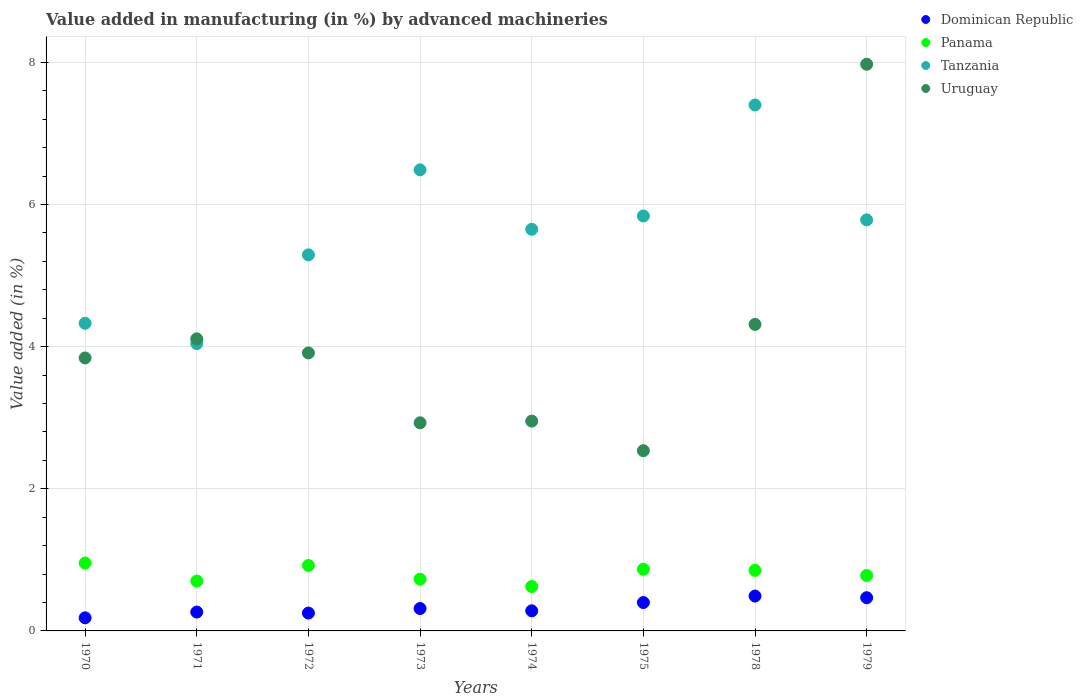What is the percentage of value added in manufacturing by advanced machineries in Dominican Republic in 1979?
Your response must be concise. 0.47. Across all years, what is the maximum percentage of value added in manufacturing by advanced machineries in Panama?
Make the answer very short. 0.95. Across all years, what is the minimum percentage of value added in manufacturing by advanced machineries in Panama?
Provide a succinct answer. 0.62. In which year was the percentage of value added in manufacturing by advanced machineries in Dominican Republic maximum?
Your answer should be compact. 1978. In which year was the percentage of value added in manufacturing by advanced machineries in Tanzania minimum?
Ensure brevity in your answer.  1971. What is the total percentage of value added in manufacturing by advanced machineries in Panama in the graph?
Keep it short and to the point. 6.43. What is the difference between the percentage of value added in manufacturing by advanced machineries in Uruguay in 1972 and that in 1975?
Give a very brief answer. 1.38. What is the difference between the percentage of value added in manufacturing by advanced machineries in Dominican Republic in 1972 and the percentage of value added in manufacturing by advanced machineries in Tanzania in 1970?
Your response must be concise. -4.08. What is the average percentage of value added in manufacturing by advanced machineries in Panama per year?
Your answer should be compact. 0.8. In the year 1978, what is the difference between the percentage of value added in manufacturing by advanced machineries in Panama and percentage of value added in manufacturing by advanced machineries in Tanzania?
Offer a very short reply. -6.55. In how many years, is the percentage of value added in manufacturing by advanced machineries in Panama greater than 0.4 %?
Ensure brevity in your answer.  8. What is the ratio of the percentage of value added in manufacturing by advanced machineries in Tanzania in 1974 to that in 1979?
Your answer should be very brief. 0.98. Is the difference between the percentage of value added in manufacturing by advanced machineries in Panama in 1970 and 1975 greater than the difference between the percentage of value added in manufacturing by advanced machineries in Tanzania in 1970 and 1975?
Your answer should be compact. Yes. What is the difference between the highest and the second highest percentage of value added in manufacturing by advanced machineries in Dominican Republic?
Keep it short and to the point. 0.02. What is the difference between the highest and the lowest percentage of value added in manufacturing by advanced machineries in Panama?
Give a very brief answer. 0.33. In how many years, is the percentage of value added in manufacturing by advanced machineries in Dominican Republic greater than the average percentage of value added in manufacturing by advanced machineries in Dominican Republic taken over all years?
Ensure brevity in your answer.  3. Is the sum of the percentage of value added in manufacturing by advanced machineries in Uruguay in 1970 and 1979 greater than the maximum percentage of value added in manufacturing by advanced machineries in Panama across all years?
Your answer should be compact. Yes. Does the percentage of value added in manufacturing by advanced machineries in Panama monotonically increase over the years?
Offer a terse response. No. Is the percentage of value added in manufacturing by advanced machineries in Uruguay strictly greater than the percentage of value added in manufacturing by advanced machineries in Tanzania over the years?
Ensure brevity in your answer.  No. Is the percentage of value added in manufacturing by advanced machineries in Dominican Republic strictly less than the percentage of value added in manufacturing by advanced machineries in Uruguay over the years?
Your answer should be very brief. Yes. How many dotlines are there?
Your response must be concise. 4. What is the difference between two consecutive major ticks on the Y-axis?
Provide a short and direct response. 2. Does the graph contain grids?
Give a very brief answer. Yes. How are the legend labels stacked?
Make the answer very short. Vertical. What is the title of the graph?
Keep it short and to the point. Value added in manufacturing (in %) by advanced machineries. What is the label or title of the Y-axis?
Your answer should be very brief. Value added (in %). What is the Value added (in %) of Dominican Republic in 1970?
Your answer should be very brief. 0.18. What is the Value added (in %) in Panama in 1970?
Your response must be concise. 0.95. What is the Value added (in %) in Tanzania in 1970?
Your answer should be very brief. 4.33. What is the Value added (in %) of Uruguay in 1970?
Offer a terse response. 3.84. What is the Value added (in %) in Dominican Republic in 1971?
Give a very brief answer. 0.27. What is the Value added (in %) of Panama in 1971?
Your response must be concise. 0.7. What is the Value added (in %) in Tanzania in 1971?
Ensure brevity in your answer.  4.04. What is the Value added (in %) of Uruguay in 1971?
Your answer should be very brief. 4.11. What is the Value added (in %) of Dominican Republic in 1972?
Give a very brief answer. 0.25. What is the Value added (in %) of Panama in 1972?
Your answer should be compact. 0.92. What is the Value added (in %) of Tanzania in 1972?
Make the answer very short. 5.29. What is the Value added (in %) in Uruguay in 1972?
Offer a terse response. 3.91. What is the Value added (in %) of Dominican Republic in 1973?
Your answer should be compact. 0.32. What is the Value added (in %) in Panama in 1973?
Your response must be concise. 0.73. What is the Value added (in %) of Tanzania in 1973?
Make the answer very short. 6.49. What is the Value added (in %) in Uruguay in 1973?
Provide a succinct answer. 2.93. What is the Value added (in %) of Dominican Republic in 1974?
Keep it short and to the point. 0.28. What is the Value added (in %) of Panama in 1974?
Offer a very short reply. 0.62. What is the Value added (in %) in Tanzania in 1974?
Your response must be concise. 5.65. What is the Value added (in %) in Uruguay in 1974?
Ensure brevity in your answer.  2.95. What is the Value added (in %) of Dominican Republic in 1975?
Your answer should be very brief. 0.4. What is the Value added (in %) of Panama in 1975?
Ensure brevity in your answer.  0.87. What is the Value added (in %) in Tanzania in 1975?
Make the answer very short. 5.84. What is the Value added (in %) of Uruguay in 1975?
Provide a succinct answer. 2.54. What is the Value added (in %) of Dominican Republic in 1978?
Ensure brevity in your answer.  0.49. What is the Value added (in %) in Panama in 1978?
Offer a very short reply. 0.85. What is the Value added (in %) of Tanzania in 1978?
Make the answer very short. 7.4. What is the Value added (in %) of Uruguay in 1978?
Provide a succinct answer. 4.31. What is the Value added (in %) of Dominican Republic in 1979?
Provide a short and direct response. 0.47. What is the Value added (in %) in Panama in 1979?
Your answer should be very brief. 0.78. What is the Value added (in %) of Tanzania in 1979?
Offer a terse response. 5.78. What is the Value added (in %) of Uruguay in 1979?
Provide a short and direct response. 7.97. Across all years, what is the maximum Value added (in %) of Dominican Republic?
Your response must be concise. 0.49. Across all years, what is the maximum Value added (in %) of Panama?
Provide a short and direct response. 0.95. Across all years, what is the maximum Value added (in %) in Tanzania?
Make the answer very short. 7.4. Across all years, what is the maximum Value added (in %) in Uruguay?
Your answer should be compact. 7.97. Across all years, what is the minimum Value added (in %) in Dominican Republic?
Your response must be concise. 0.18. Across all years, what is the minimum Value added (in %) of Panama?
Your answer should be compact. 0.62. Across all years, what is the minimum Value added (in %) of Tanzania?
Offer a terse response. 4.04. Across all years, what is the minimum Value added (in %) of Uruguay?
Ensure brevity in your answer.  2.54. What is the total Value added (in %) of Dominican Republic in the graph?
Make the answer very short. 2.66. What is the total Value added (in %) of Panama in the graph?
Your response must be concise. 6.43. What is the total Value added (in %) in Tanzania in the graph?
Provide a short and direct response. 44.82. What is the total Value added (in %) of Uruguay in the graph?
Offer a terse response. 32.56. What is the difference between the Value added (in %) of Dominican Republic in 1970 and that in 1971?
Offer a terse response. -0.08. What is the difference between the Value added (in %) of Panama in 1970 and that in 1971?
Make the answer very short. 0.25. What is the difference between the Value added (in %) of Tanzania in 1970 and that in 1971?
Provide a succinct answer. 0.29. What is the difference between the Value added (in %) in Uruguay in 1970 and that in 1971?
Give a very brief answer. -0.27. What is the difference between the Value added (in %) of Dominican Republic in 1970 and that in 1972?
Give a very brief answer. -0.07. What is the difference between the Value added (in %) in Panama in 1970 and that in 1972?
Make the answer very short. 0.03. What is the difference between the Value added (in %) of Tanzania in 1970 and that in 1972?
Offer a terse response. -0.96. What is the difference between the Value added (in %) of Uruguay in 1970 and that in 1972?
Provide a succinct answer. -0.07. What is the difference between the Value added (in %) in Dominican Republic in 1970 and that in 1973?
Make the answer very short. -0.13. What is the difference between the Value added (in %) of Panama in 1970 and that in 1973?
Ensure brevity in your answer.  0.23. What is the difference between the Value added (in %) in Tanzania in 1970 and that in 1973?
Provide a succinct answer. -2.16. What is the difference between the Value added (in %) of Uruguay in 1970 and that in 1973?
Provide a succinct answer. 0.91. What is the difference between the Value added (in %) in Dominican Republic in 1970 and that in 1974?
Provide a short and direct response. -0.1. What is the difference between the Value added (in %) in Panama in 1970 and that in 1974?
Provide a succinct answer. 0.33. What is the difference between the Value added (in %) of Tanzania in 1970 and that in 1974?
Give a very brief answer. -1.32. What is the difference between the Value added (in %) of Uruguay in 1970 and that in 1974?
Offer a terse response. 0.89. What is the difference between the Value added (in %) in Dominican Republic in 1970 and that in 1975?
Ensure brevity in your answer.  -0.21. What is the difference between the Value added (in %) of Panama in 1970 and that in 1975?
Keep it short and to the point. 0.09. What is the difference between the Value added (in %) in Tanzania in 1970 and that in 1975?
Make the answer very short. -1.51. What is the difference between the Value added (in %) in Uruguay in 1970 and that in 1975?
Give a very brief answer. 1.3. What is the difference between the Value added (in %) in Dominican Republic in 1970 and that in 1978?
Make the answer very short. -0.31. What is the difference between the Value added (in %) of Panama in 1970 and that in 1978?
Your response must be concise. 0.1. What is the difference between the Value added (in %) in Tanzania in 1970 and that in 1978?
Offer a very short reply. -3.07. What is the difference between the Value added (in %) in Uruguay in 1970 and that in 1978?
Your answer should be compact. -0.47. What is the difference between the Value added (in %) of Dominican Republic in 1970 and that in 1979?
Ensure brevity in your answer.  -0.28. What is the difference between the Value added (in %) in Panama in 1970 and that in 1979?
Your answer should be compact. 0.17. What is the difference between the Value added (in %) of Tanzania in 1970 and that in 1979?
Your answer should be compact. -1.46. What is the difference between the Value added (in %) in Uruguay in 1970 and that in 1979?
Make the answer very short. -4.13. What is the difference between the Value added (in %) in Dominican Republic in 1971 and that in 1972?
Offer a terse response. 0.01. What is the difference between the Value added (in %) in Panama in 1971 and that in 1972?
Offer a very short reply. -0.22. What is the difference between the Value added (in %) of Tanzania in 1971 and that in 1972?
Keep it short and to the point. -1.25. What is the difference between the Value added (in %) in Uruguay in 1971 and that in 1972?
Offer a very short reply. 0.2. What is the difference between the Value added (in %) in Dominican Republic in 1971 and that in 1973?
Provide a succinct answer. -0.05. What is the difference between the Value added (in %) in Panama in 1971 and that in 1973?
Keep it short and to the point. -0.03. What is the difference between the Value added (in %) of Tanzania in 1971 and that in 1973?
Ensure brevity in your answer.  -2.44. What is the difference between the Value added (in %) in Uruguay in 1971 and that in 1973?
Offer a very short reply. 1.18. What is the difference between the Value added (in %) in Dominican Republic in 1971 and that in 1974?
Ensure brevity in your answer.  -0.02. What is the difference between the Value added (in %) in Panama in 1971 and that in 1974?
Your answer should be very brief. 0.08. What is the difference between the Value added (in %) in Tanzania in 1971 and that in 1974?
Provide a succinct answer. -1.61. What is the difference between the Value added (in %) in Uruguay in 1971 and that in 1974?
Offer a terse response. 1.16. What is the difference between the Value added (in %) of Dominican Republic in 1971 and that in 1975?
Keep it short and to the point. -0.13. What is the difference between the Value added (in %) of Panama in 1971 and that in 1975?
Provide a succinct answer. -0.17. What is the difference between the Value added (in %) in Tanzania in 1971 and that in 1975?
Provide a short and direct response. -1.8. What is the difference between the Value added (in %) of Uruguay in 1971 and that in 1975?
Provide a succinct answer. 1.57. What is the difference between the Value added (in %) of Dominican Republic in 1971 and that in 1978?
Make the answer very short. -0.23. What is the difference between the Value added (in %) in Panama in 1971 and that in 1978?
Give a very brief answer. -0.15. What is the difference between the Value added (in %) of Tanzania in 1971 and that in 1978?
Provide a succinct answer. -3.36. What is the difference between the Value added (in %) in Uruguay in 1971 and that in 1978?
Offer a terse response. -0.2. What is the difference between the Value added (in %) of Dominican Republic in 1971 and that in 1979?
Ensure brevity in your answer.  -0.2. What is the difference between the Value added (in %) in Panama in 1971 and that in 1979?
Provide a succinct answer. -0.08. What is the difference between the Value added (in %) in Tanzania in 1971 and that in 1979?
Provide a short and direct response. -1.74. What is the difference between the Value added (in %) in Uruguay in 1971 and that in 1979?
Offer a terse response. -3.86. What is the difference between the Value added (in %) in Dominican Republic in 1972 and that in 1973?
Offer a very short reply. -0.06. What is the difference between the Value added (in %) of Panama in 1972 and that in 1973?
Your answer should be very brief. 0.19. What is the difference between the Value added (in %) in Tanzania in 1972 and that in 1973?
Make the answer very short. -1.2. What is the difference between the Value added (in %) in Uruguay in 1972 and that in 1973?
Give a very brief answer. 0.98. What is the difference between the Value added (in %) of Dominican Republic in 1972 and that in 1974?
Make the answer very short. -0.03. What is the difference between the Value added (in %) of Panama in 1972 and that in 1974?
Provide a succinct answer. 0.3. What is the difference between the Value added (in %) in Tanzania in 1972 and that in 1974?
Provide a short and direct response. -0.36. What is the difference between the Value added (in %) of Uruguay in 1972 and that in 1974?
Keep it short and to the point. 0.96. What is the difference between the Value added (in %) in Dominican Republic in 1972 and that in 1975?
Provide a succinct answer. -0.15. What is the difference between the Value added (in %) of Panama in 1972 and that in 1975?
Ensure brevity in your answer.  0.05. What is the difference between the Value added (in %) in Tanzania in 1972 and that in 1975?
Provide a short and direct response. -0.55. What is the difference between the Value added (in %) in Uruguay in 1972 and that in 1975?
Keep it short and to the point. 1.38. What is the difference between the Value added (in %) of Dominican Republic in 1972 and that in 1978?
Your response must be concise. -0.24. What is the difference between the Value added (in %) of Panama in 1972 and that in 1978?
Keep it short and to the point. 0.07. What is the difference between the Value added (in %) of Tanzania in 1972 and that in 1978?
Ensure brevity in your answer.  -2.11. What is the difference between the Value added (in %) in Uruguay in 1972 and that in 1978?
Make the answer very short. -0.4. What is the difference between the Value added (in %) in Dominican Republic in 1972 and that in 1979?
Provide a short and direct response. -0.22. What is the difference between the Value added (in %) of Panama in 1972 and that in 1979?
Provide a succinct answer. 0.14. What is the difference between the Value added (in %) in Tanzania in 1972 and that in 1979?
Make the answer very short. -0.49. What is the difference between the Value added (in %) in Uruguay in 1972 and that in 1979?
Make the answer very short. -4.06. What is the difference between the Value added (in %) of Dominican Republic in 1973 and that in 1974?
Provide a short and direct response. 0.03. What is the difference between the Value added (in %) in Panama in 1973 and that in 1974?
Your response must be concise. 0.1. What is the difference between the Value added (in %) in Tanzania in 1973 and that in 1974?
Keep it short and to the point. 0.84. What is the difference between the Value added (in %) in Uruguay in 1973 and that in 1974?
Offer a terse response. -0.02. What is the difference between the Value added (in %) in Dominican Republic in 1973 and that in 1975?
Make the answer very short. -0.08. What is the difference between the Value added (in %) in Panama in 1973 and that in 1975?
Provide a succinct answer. -0.14. What is the difference between the Value added (in %) of Tanzania in 1973 and that in 1975?
Make the answer very short. 0.65. What is the difference between the Value added (in %) of Uruguay in 1973 and that in 1975?
Offer a terse response. 0.39. What is the difference between the Value added (in %) of Dominican Republic in 1973 and that in 1978?
Provide a short and direct response. -0.18. What is the difference between the Value added (in %) in Panama in 1973 and that in 1978?
Make the answer very short. -0.12. What is the difference between the Value added (in %) of Tanzania in 1973 and that in 1978?
Your answer should be compact. -0.91. What is the difference between the Value added (in %) in Uruguay in 1973 and that in 1978?
Provide a succinct answer. -1.38. What is the difference between the Value added (in %) of Dominican Republic in 1973 and that in 1979?
Give a very brief answer. -0.15. What is the difference between the Value added (in %) in Panama in 1973 and that in 1979?
Your answer should be compact. -0.05. What is the difference between the Value added (in %) of Tanzania in 1973 and that in 1979?
Your answer should be very brief. 0.7. What is the difference between the Value added (in %) of Uruguay in 1973 and that in 1979?
Offer a terse response. -5.04. What is the difference between the Value added (in %) in Dominican Republic in 1974 and that in 1975?
Give a very brief answer. -0.12. What is the difference between the Value added (in %) in Panama in 1974 and that in 1975?
Make the answer very short. -0.24. What is the difference between the Value added (in %) of Tanzania in 1974 and that in 1975?
Your response must be concise. -0.19. What is the difference between the Value added (in %) in Uruguay in 1974 and that in 1975?
Provide a succinct answer. 0.42. What is the difference between the Value added (in %) in Dominican Republic in 1974 and that in 1978?
Keep it short and to the point. -0.21. What is the difference between the Value added (in %) of Panama in 1974 and that in 1978?
Ensure brevity in your answer.  -0.23. What is the difference between the Value added (in %) of Tanzania in 1974 and that in 1978?
Give a very brief answer. -1.75. What is the difference between the Value added (in %) of Uruguay in 1974 and that in 1978?
Give a very brief answer. -1.36. What is the difference between the Value added (in %) in Dominican Republic in 1974 and that in 1979?
Give a very brief answer. -0.18. What is the difference between the Value added (in %) of Panama in 1974 and that in 1979?
Ensure brevity in your answer.  -0.16. What is the difference between the Value added (in %) in Tanzania in 1974 and that in 1979?
Keep it short and to the point. -0.13. What is the difference between the Value added (in %) in Uruguay in 1974 and that in 1979?
Give a very brief answer. -5.02. What is the difference between the Value added (in %) in Dominican Republic in 1975 and that in 1978?
Your answer should be compact. -0.09. What is the difference between the Value added (in %) in Panama in 1975 and that in 1978?
Make the answer very short. 0.02. What is the difference between the Value added (in %) in Tanzania in 1975 and that in 1978?
Your response must be concise. -1.56. What is the difference between the Value added (in %) of Uruguay in 1975 and that in 1978?
Provide a short and direct response. -1.78. What is the difference between the Value added (in %) in Dominican Republic in 1975 and that in 1979?
Your answer should be very brief. -0.07. What is the difference between the Value added (in %) in Panama in 1975 and that in 1979?
Offer a terse response. 0.09. What is the difference between the Value added (in %) of Tanzania in 1975 and that in 1979?
Offer a terse response. 0.05. What is the difference between the Value added (in %) in Uruguay in 1975 and that in 1979?
Ensure brevity in your answer.  -5.44. What is the difference between the Value added (in %) in Dominican Republic in 1978 and that in 1979?
Offer a terse response. 0.02. What is the difference between the Value added (in %) in Panama in 1978 and that in 1979?
Your response must be concise. 0.07. What is the difference between the Value added (in %) in Tanzania in 1978 and that in 1979?
Offer a terse response. 1.62. What is the difference between the Value added (in %) of Uruguay in 1978 and that in 1979?
Give a very brief answer. -3.66. What is the difference between the Value added (in %) in Dominican Republic in 1970 and the Value added (in %) in Panama in 1971?
Offer a terse response. -0.52. What is the difference between the Value added (in %) of Dominican Republic in 1970 and the Value added (in %) of Tanzania in 1971?
Keep it short and to the point. -3.86. What is the difference between the Value added (in %) of Dominican Republic in 1970 and the Value added (in %) of Uruguay in 1971?
Provide a short and direct response. -3.92. What is the difference between the Value added (in %) in Panama in 1970 and the Value added (in %) in Tanzania in 1971?
Your answer should be very brief. -3.09. What is the difference between the Value added (in %) in Panama in 1970 and the Value added (in %) in Uruguay in 1971?
Your answer should be compact. -3.15. What is the difference between the Value added (in %) in Tanzania in 1970 and the Value added (in %) in Uruguay in 1971?
Keep it short and to the point. 0.22. What is the difference between the Value added (in %) of Dominican Republic in 1970 and the Value added (in %) of Panama in 1972?
Keep it short and to the point. -0.74. What is the difference between the Value added (in %) of Dominican Republic in 1970 and the Value added (in %) of Tanzania in 1972?
Ensure brevity in your answer.  -5.11. What is the difference between the Value added (in %) in Dominican Republic in 1970 and the Value added (in %) in Uruguay in 1972?
Your answer should be very brief. -3.73. What is the difference between the Value added (in %) in Panama in 1970 and the Value added (in %) in Tanzania in 1972?
Provide a short and direct response. -4.34. What is the difference between the Value added (in %) of Panama in 1970 and the Value added (in %) of Uruguay in 1972?
Offer a very short reply. -2.96. What is the difference between the Value added (in %) in Tanzania in 1970 and the Value added (in %) in Uruguay in 1972?
Your answer should be compact. 0.42. What is the difference between the Value added (in %) of Dominican Republic in 1970 and the Value added (in %) of Panama in 1973?
Ensure brevity in your answer.  -0.54. What is the difference between the Value added (in %) in Dominican Republic in 1970 and the Value added (in %) in Tanzania in 1973?
Your response must be concise. -6.3. What is the difference between the Value added (in %) in Dominican Republic in 1970 and the Value added (in %) in Uruguay in 1973?
Keep it short and to the point. -2.74. What is the difference between the Value added (in %) of Panama in 1970 and the Value added (in %) of Tanzania in 1973?
Ensure brevity in your answer.  -5.53. What is the difference between the Value added (in %) of Panama in 1970 and the Value added (in %) of Uruguay in 1973?
Your answer should be very brief. -1.97. What is the difference between the Value added (in %) of Tanzania in 1970 and the Value added (in %) of Uruguay in 1973?
Your response must be concise. 1.4. What is the difference between the Value added (in %) of Dominican Republic in 1970 and the Value added (in %) of Panama in 1974?
Provide a short and direct response. -0.44. What is the difference between the Value added (in %) in Dominican Republic in 1970 and the Value added (in %) in Tanzania in 1974?
Your answer should be very brief. -5.47. What is the difference between the Value added (in %) of Dominican Republic in 1970 and the Value added (in %) of Uruguay in 1974?
Your answer should be compact. -2.77. What is the difference between the Value added (in %) of Panama in 1970 and the Value added (in %) of Tanzania in 1974?
Give a very brief answer. -4.7. What is the difference between the Value added (in %) of Panama in 1970 and the Value added (in %) of Uruguay in 1974?
Your answer should be very brief. -2. What is the difference between the Value added (in %) of Tanzania in 1970 and the Value added (in %) of Uruguay in 1974?
Ensure brevity in your answer.  1.38. What is the difference between the Value added (in %) in Dominican Republic in 1970 and the Value added (in %) in Panama in 1975?
Make the answer very short. -0.68. What is the difference between the Value added (in %) of Dominican Republic in 1970 and the Value added (in %) of Tanzania in 1975?
Your answer should be compact. -5.65. What is the difference between the Value added (in %) of Dominican Republic in 1970 and the Value added (in %) of Uruguay in 1975?
Ensure brevity in your answer.  -2.35. What is the difference between the Value added (in %) of Panama in 1970 and the Value added (in %) of Tanzania in 1975?
Ensure brevity in your answer.  -4.88. What is the difference between the Value added (in %) of Panama in 1970 and the Value added (in %) of Uruguay in 1975?
Ensure brevity in your answer.  -1.58. What is the difference between the Value added (in %) of Tanzania in 1970 and the Value added (in %) of Uruguay in 1975?
Make the answer very short. 1.79. What is the difference between the Value added (in %) of Dominican Republic in 1970 and the Value added (in %) of Panama in 1978?
Your answer should be compact. -0.67. What is the difference between the Value added (in %) of Dominican Republic in 1970 and the Value added (in %) of Tanzania in 1978?
Your answer should be compact. -7.22. What is the difference between the Value added (in %) in Dominican Republic in 1970 and the Value added (in %) in Uruguay in 1978?
Make the answer very short. -4.13. What is the difference between the Value added (in %) of Panama in 1970 and the Value added (in %) of Tanzania in 1978?
Offer a very short reply. -6.45. What is the difference between the Value added (in %) of Panama in 1970 and the Value added (in %) of Uruguay in 1978?
Your response must be concise. -3.36. What is the difference between the Value added (in %) in Tanzania in 1970 and the Value added (in %) in Uruguay in 1978?
Your answer should be compact. 0.01. What is the difference between the Value added (in %) in Dominican Republic in 1970 and the Value added (in %) in Panama in 1979?
Your response must be concise. -0.6. What is the difference between the Value added (in %) of Dominican Republic in 1970 and the Value added (in %) of Tanzania in 1979?
Your answer should be compact. -5.6. What is the difference between the Value added (in %) of Dominican Republic in 1970 and the Value added (in %) of Uruguay in 1979?
Your answer should be compact. -7.79. What is the difference between the Value added (in %) in Panama in 1970 and the Value added (in %) in Tanzania in 1979?
Offer a very short reply. -4.83. What is the difference between the Value added (in %) in Panama in 1970 and the Value added (in %) in Uruguay in 1979?
Make the answer very short. -7.02. What is the difference between the Value added (in %) in Tanzania in 1970 and the Value added (in %) in Uruguay in 1979?
Make the answer very short. -3.65. What is the difference between the Value added (in %) of Dominican Republic in 1971 and the Value added (in %) of Panama in 1972?
Ensure brevity in your answer.  -0.66. What is the difference between the Value added (in %) in Dominican Republic in 1971 and the Value added (in %) in Tanzania in 1972?
Keep it short and to the point. -5.03. What is the difference between the Value added (in %) in Dominican Republic in 1971 and the Value added (in %) in Uruguay in 1972?
Your answer should be compact. -3.65. What is the difference between the Value added (in %) in Panama in 1971 and the Value added (in %) in Tanzania in 1972?
Ensure brevity in your answer.  -4.59. What is the difference between the Value added (in %) in Panama in 1971 and the Value added (in %) in Uruguay in 1972?
Provide a short and direct response. -3.21. What is the difference between the Value added (in %) of Tanzania in 1971 and the Value added (in %) of Uruguay in 1972?
Keep it short and to the point. 0.13. What is the difference between the Value added (in %) of Dominican Republic in 1971 and the Value added (in %) of Panama in 1973?
Offer a very short reply. -0.46. What is the difference between the Value added (in %) in Dominican Republic in 1971 and the Value added (in %) in Tanzania in 1973?
Provide a short and direct response. -6.22. What is the difference between the Value added (in %) of Dominican Republic in 1971 and the Value added (in %) of Uruguay in 1973?
Give a very brief answer. -2.66. What is the difference between the Value added (in %) of Panama in 1971 and the Value added (in %) of Tanzania in 1973?
Provide a succinct answer. -5.79. What is the difference between the Value added (in %) of Panama in 1971 and the Value added (in %) of Uruguay in 1973?
Your answer should be very brief. -2.23. What is the difference between the Value added (in %) in Tanzania in 1971 and the Value added (in %) in Uruguay in 1973?
Your answer should be compact. 1.11. What is the difference between the Value added (in %) of Dominican Republic in 1971 and the Value added (in %) of Panama in 1974?
Your answer should be compact. -0.36. What is the difference between the Value added (in %) of Dominican Republic in 1971 and the Value added (in %) of Tanzania in 1974?
Make the answer very short. -5.39. What is the difference between the Value added (in %) of Dominican Republic in 1971 and the Value added (in %) of Uruguay in 1974?
Your answer should be very brief. -2.69. What is the difference between the Value added (in %) in Panama in 1971 and the Value added (in %) in Tanzania in 1974?
Your answer should be compact. -4.95. What is the difference between the Value added (in %) in Panama in 1971 and the Value added (in %) in Uruguay in 1974?
Make the answer very short. -2.25. What is the difference between the Value added (in %) of Tanzania in 1971 and the Value added (in %) of Uruguay in 1974?
Make the answer very short. 1.09. What is the difference between the Value added (in %) in Dominican Republic in 1971 and the Value added (in %) in Panama in 1975?
Your answer should be compact. -0.6. What is the difference between the Value added (in %) in Dominican Republic in 1971 and the Value added (in %) in Tanzania in 1975?
Provide a succinct answer. -5.57. What is the difference between the Value added (in %) in Dominican Republic in 1971 and the Value added (in %) in Uruguay in 1975?
Your response must be concise. -2.27. What is the difference between the Value added (in %) in Panama in 1971 and the Value added (in %) in Tanzania in 1975?
Your response must be concise. -5.14. What is the difference between the Value added (in %) in Panama in 1971 and the Value added (in %) in Uruguay in 1975?
Make the answer very short. -1.83. What is the difference between the Value added (in %) in Tanzania in 1971 and the Value added (in %) in Uruguay in 1975?
Your response must be concise. 1.51. What is the difference between the Value added (in %) of Dominican Republic in 1971 and the Value added (in %) of Panama in 1978?
Ensure brevity in your answer.  -0.59. What is the difference between the Value added (in %) in Dominican Republic in 1971 and the Value added (in %) in Tanzania in 1978?
Give a very brief answer. -7.13. What is the difference between the Value added (in %) in Dominican Republic in 1971 and the Value added (in %) in Uruguay in 1978?
Offer a very short reply. -4.05. What is the difference between the Value added (in %) in Panama in 1971 and the Value added (in %) in Tanzania in 1978?
Your answer should be compact. -6.7. What is the difference between the Value added (in %) in Panama in 1971 and the Value added (in %) in Uruguay in 1978?
Keep it short and to the point. -3.61. What is the difference between the Value added (in %) of Tanzania in 1971 and the Value added (in %) of Uruguay in 1978?
Your answer should be compact. -0.27. What is the difference between the Value added (in %) in Dominican Republic in 1971 and the Value added (in %) in Panama in 1979?
Your response must be concise. -0.51. What is the difference between the Value added (in %) in Dominican Republic in 1971 and the Value added (in %) in Tanzania in 1979?
Ensure brevity in your answer.  -5.52. What is the difference between the Value added (in %) in Dominican Republic in 1971 and the Value added (in %) in Uruguay in 1979?
Your answer should be compact. -7.71. What is the difference between the Value added (in %) in Panama in 1971 and the Value added (in %) in Tanzania in 1979?
Make the answer very short. -5.08. What is the difference between the Value added (in %) in Panama in 1971 and the Value added (in %) in Uruguay in 1979?
Your answer should be very brief. -7.27. What is the difference between the Value added (in %) of Tanzania in 1971 and the Value added (in %) of Uruguay in 1979?
Make the answer very short. -3.93. What is the difference between the Value added (in %) of Dominican Republic in 1972 and the Value added (in %) of Panama in 1973?
Keep it short and to the point. -0.48. What is the difference between the Value added (in %) of Dominican Republic in 1972 and the Value added (in %) of Tanzania in 1973?
Provide a succinct answer. -6.24. What is the difference between the Value added (in %) of Dominican Republic in 1972 and the Value added (in %) of Uruguay in 1973?
Keep it short and to the point. -2.68. What is the difference between the Value added (in %) of Panama in 1972 and the Value added (in %) of Tanzania in 1973?
Provide a short and direct response. -5.57. What is the difference between the Value added (in %) in Panama in 1972 and the Value added (in %) in Uruguay in 1973?
Offer a terse response. -2.01. What is the difference between the Value added (in %) of Tanzania in 1972 and the Value added (in %) of Uruguay in 1973?
Ensure brevity in your answer.  2.36. What is the difference between the Value added (in %) of Dominican Republic in 1972 and the Value added (in %) of Panama in 1974?
Your answer should be compact. -0.37. What is the difference between the Value added (in %) in Dominican Republic in 1972 and the Value added (in %) in Tanzania in 1974?
Your answer should be very brief. -5.4. What is the difference between the Value added (in %) in Dominican Republic in 1972 and the Value added (in %) in Uruguay in 1974?
Give a very brief answer. -2.7. What is the difference between the Value added (in %) of Panama in 1972 and the Value added (in %) of Tanzania in 1974?
Keep it short and to the point. -4.73. What is the difference between the Value added (in %) of Panama in 1972 and the Value added (in %) of Uruguay in 1974?
Give a very brief answer. -2.03. What is the difference between the Value added (in %) in Tanzania in 1972 and the Value added (in %) in Uruguay in 1974?
Ensure brevity in your answer.  2.34. What is the difference between the Value added (in %) of Dominican Republic in 1972 and the Value added (in %) of Panama in 1975?
Offer a very short reply. -0.62. What is the difference between the Value added (in %) of Dominican Republic in 1972 and the Value added (in %) of Tanzania in 1975?
Offer a terse response. -5.59. What is the difference between the Value added (in %) of Dominican Republic in 1972 and the Value added (in %) of Uruguay in 1975?
Give a very brief answer. -2.28. What is the difference between the Value added (in %) in Panama in 1972 and the Value added (in %) in Tanzania in 1975?
Offer a terse response. -4.92. What is the difference between the Value added (in %) in Panama in 1972 and the Value added (in %) in Uruguay in 1975?
Your answer should be very brief. -1.61. What is the difference between the Value added (in %) in Tanzania in 1972 and the Value added (in %) in Uruguay in 1975?
Provide a succinct answer. 2.76. What is the difference between the Value added (in %) of Dominican Republic in 1972 and the Value added (in %) of Panama in 1978?
Give a very brief answer. -0.6. What is the difference between the Value added (in %) in Dominican Republic in 1972 and the Value added (in %) in Tanzania in 1978?
Offer a terse response. -7.15. What is the difference between the Value added (in %) in Dominican Republic in 1972 and the Value added (in %) in Uruguay in 1978?
Provide a short and direct response. -4.06. What is the difference between the Value added (in %) in Panama in 1972 and the Value added (in %) in Tanzania in 1978?
Your response must be concise. -6.48. What is the difference between the Value added (in %) of Panama in 1972 and the Value added (in %) of Uruguay in 1978?
Offer a terse response. -3.39. What is the difference between the Value added (in %) in Tanzania in 1972 and the Value added (in %) in Uruguay in 1978?
Your response must be concise. 0.98. What is the difference between the Value added (in %) of Dominican Republic in 1972 and the Value added (in %) of Panama in 1979?
Your response must be concise. -0.53. What is the difference between the Value added (in %) of Dominican Republic in 1972 and the Value added (in %) of Tanzania in 1979?
Your answer should be very brief. -5.53. What is the difference between the Value added (in %) in Dominican Republic in 1972 and the Value added (in %) in Uruguay in 1979?
Your answer should be very brief. -7.72. What is the difference between the Value added (in %) of Panama in 1972 and the Value added (in %) of Tanzania in 1979?
Your answer should be compact. -4.86. What is the difference between the Value added (in %) of Panama in 1972 and the Value added (in %) of Uruguay in 1979?
Provide a succinct answer. -7.05. What is the difference between the Value added (in %) of Tanzania in 1972 and the Value added (in %) of Uruguay in 1979?
Your response must be concise. -2.68. What is the difference between the Value added (in %) in Dominican Republic in 1973 and the Value added (in %) in Panama in 1974?
Provide a short and direct response. -0.31. What is the difference between the Value added (in %) in Dominican Republic in 1973 and the Value added (in %) in Tanzania in 1974?
Your answer should be compact. -5.34. What is the difference between the Value added (in %) in Dominican Republic in 1973 and the Value added (in %) in Uruguay in 1974?
Ensure brevity in your answer.  -2.64. What is the difference between the Value added (in %) in Panama in 1973 and the Value added (in %) in Tanzania in 1974?
Offer a terse response. -4.92. What is the difference between the Value added (in %) of Panama in 1973 and the Value added (in %) of Uruguay in 1974?
Ensure brevity in your answer.  -2.22. What is the difference between the Value added (in %) in Tanzania in 1973 and the Value added (in %) in Uruguay in 1974?
Offer a terse response. 3.54. What is the difference between the Value added (in %) in Dominican Republic in 1973 and the Value added (in %) in Panama in 1975?
Your answer should be very brief. -0.55. What is the difference between the Value added (in %) of Dominican Republic in 1973 and the Value added (in %) of Tanzania in 1975?
Offer a terse response. -5.52. What is the difference between the Value added (in %) in Dominican Republic in 1973 and the Value added (in %) in Uruguay in 1975?
Make the answer very short. -2.22. What is the difference between the Value added (in %) in Panama in 1973 and the Value added (in %) in Tanzania in 1975?
Provide a succinct answer. -5.11. What is the difference between the Value added (in %) of Panama in 1973 and the Value added (in %) of Uruguay in 1975?
Provide a short and direct response. -1.81. What is the difference between the Value added (in %) in Tanzania in 1973 and the Value added (in %) in Uruguay in 1975?
Make the answer very short. 3.95. What is the difference between the Value added (in %) of Dominican Republic in 1973 and the Value added (in %) of Panama in 1978?
Make the answer very short. -0.54. What is the difference between the Value added (in %) in Dominican Republic in 1973 and the Value added (in %) in Tanzania in 1978?
Your answer should be very brief. -7.08. What is the difference between the Value added (in %) in Dominican Republic in 1973 and the Value added (in %) in Uruguay in 1978?
Your answer should be very brief. -4. What is the difference between the Value added (in %) of Panama in 1973 and the Value added (in %) of Tanzania in 1978?
Make the answer very short. -6.67. What is the difference between the Value added (in %) in Panama in 1973 and the Value added (in %) in Uruguay in 1978?
Keep it short and to the point. -3.58. What is the difference between the Value added (in %) in Tanzania in 1973 and the Value added (in %) in Uruguay in 1978?
Provide a short and direct response. 2.17. What is the difference between the Value added (in %) of Dominican Republic in 1973 and the Value added (in %) of Panama in 1979?
Make the answer very short. -0.46. What is the difference between the Value added (in %) in Dominican Republic in 1973 and the Value added (in %) in Tanzania in 1979?
Your answer should be very brief. -5.47. What is the difference between the Value added (in %) of Dominican Republic in 1973 and the Value added (in %) of Uruguay in 1979?
Provide a short and direct response. -7.66. What is the difference between the Value added (in %) of Panama in 1973 and the Value added (in %) of Tanzania in 1979?
Provide a succinct answer. -5.06. What is the difference between the Value added (in %) of Panama in 1973 and the Value added (in %) of Uruguay in 1979?
Make the answer very short. -7.25. What is the difference between the Value added (in %) of Tanzania in 1973 and the Value added (in %) of Uruguay in 1979?
Make the answer very short. -1.49. What is the difference between the Value added (in %) in Dominican Republic in 1974 and the Value added (in %) in Panama in 1975?
Ensure brevity in your answer.  -0.59. What is the difference between the Value added (in %) in Dominican Republic in 1974 and the Value added (in %) in Tanzania in 1975?
Your response must be concise. -5.56. What is the difference between the Value added (in %) of Dominican Republic in 1974 and the Value added (in %) of Uruguay in 1975?
Offer a very short reply. -2.25. What is the difference between the Value added (in %) in Panama in 1974 and the Value added (in %) in Tanzania in 1975?
Provide a short and direct response. -5.21. What is the difference between the Value added (in %) in Panama in 1974 and the Value added (in %) in Uruguay in 1975?
Make the answer very short. -1.91. What is the difference between the Value added (in %) in Tanzania in 1974 and the Value added (in %) in Uruguay in 1975?
Your response must be concise. 3.12. What is the difference between the Value added (in %) of Dominican Republic in 1974 and the Value added (in %) of Panama in 1978?
Give a very brief answer. -0.57. What is the difference between the Value added (in %) of Dominican Republic in 1974 and the Value added (in %) of Tanzania in 1978?
Provide a short and direct response. -7.12. What is the difference between the Value added (in %) of Dominican Republic in 1974 and the Value added (in %) of Uruguay in 1978?
Offer a terse response. -4.03. What is the difference between the Value added (in %) in Panama in 1974 and the Value added (in %) in Tanzania in 1978?
Give a very brief answer. -6.78. What is the difference between the Value added (in %) of Panama in 1974 and the Value added (in %) of Uruguay in 1978?
Give a very brief answer. -3.69. What is the difference between the Value added (in %) in Tanzania in 1974 and the Value added (in %) in Uruguay in 1978?
Offer a terse response. 1.34. What is the difference between the Value added (in %) of Dominican Republic in 1974 and the Value added (in %) of Panama in 1979?
Offer a terse response. -0.5. What is the difference between the Value added (in %) of Dominican Republic in 1974 and the Value added (in %) of Tanzania in 1979?
Provide a succinct answer. -5.5. What is the difference between the Value added (in %) in Dominican Republic in 1974 and the Value added (in %) in Uruguay in 1979?
Your answer should be compact. -7.69. What is the difference between the Value added (in %) of Panama in 1974 and the Value added (in %) of Tanzania in 1979?
Your answer should be compact. -5.16. What is the difference between the Value added (in %) in Panama in 1974 and the Value added (in %) in Uruguay in 1979?
Make the answer very short. -7.35. What is the difference between the Value added (in %) of Tanzania in 1974 and the Value added (in %) of Uruguay in 1979?
Your response must be concise. -2.32. What is the difference between the Value added (in %) in Dominican Republic in 1975 and the Value added (in %) in Panama in 1978?
Your response must be concise. -0.45. What is the difference between the Value added (in %) in Dominican Republic in 1975 and the Value added (in %) in Tanzania in 1978?
Keep it short and to the point. -7. What is the difference between the Value added (in %) of Dominican Republic in 1975 and the Value added (in %) of Uruguay in 1978?
Keep it short and to the point. -3.91. What is the difference between the Value added (in %) of Panama in 1975 and the Value added (in %) of Tanzania in 1978?
Ensure brevity in your answer.  -6.53. What is the difference between the Value added (in %) in Panama in 1975 and the Value added (in %) in Uruguay in 1978?
Offer a very short reply. -3.44. What is the difference between the Value added (in %) of Tanzania in 1975 and the Value added (in %) of Uruguay in 1978?
Keep it short and to the point. 1.53. What is the difference between the Value added (in %) of Dominican Republic in 1975 and the Value added (in %) of Panama in 1979?
Your answer should be very brief. -0.38. What is the difference between the Value added (in %) in Dominican Republic in 1975 and the Value added (in %) in Tanzania in 1979?
Keep it short and to the point. -5.38. What is the difference between the Value added (in %) of Dominican Republic in 1975 and the Value added (in %) of Uruguay in 1979?
Provide a short and direct response. -7.57. What is the difference between the Value added (in %) in Panama in 1975 and the Value added (in %) in Tanzania in 1979?
Offer a terse response. -4.92. What is the difference between the Value added (in %) of Panama in 1975 and the Value added (in %) of Uruguay in 1979?
Keep it short and to the point. -7.11. What is the difference between the Value added (in %) in Tanzania in 1975 and the Value added (in %) in Uruguay in 1979?
Ensure brevity in your answer.  -2.13. What is the difference between the Value added (in %) of Dominican Republic in 1978 and the Value added (in %) of Panama in 1979?
Provide a short and direct response. -0.29. What is the difference between the Value added (in %) in Dominican Republic in 1978 and the Value added (in %) in Tanzania in 1979?
Your answer should be compact. -5.29. What is the difference between the Value added (in %) of Dominican Republic in 1978 and the Value added (in %) of Uruguay in 1979?
Ensure brevity in your answer.  -7.48. What is the difference between the Value added (in %) in Panama in 1978 and the Value added (in %) in Tanzania in 1979?
Provide a succinct answer. -4.93. What is the difference between the Value added (in %) in Panama in 1978 and the Value added (in %) in Uruguay in 1979?
Provide a succinct answer. -7.12. What is the difference between the Value added (in %) in Tanzania in 1978 and the Value added (in %) in Uruguay in 1979?
Your answer should be very brief. -0.57. What is the average Value added (in %) of Dominican Republic per year?
Your answer should be very brief. 0.33. What is the average Value added (in %) of Panama per year?
Keep it short and to the point. 0.8. What is the average Value added (in %) in Tanzania per year?
Your response must be concise. 5.6. What is the average Value added (in %) of Uruguay per year?
Give a very brief answer. 4.07. In the year 1970, what is the difference between the Value added (in %) in Dominican Republic and Value added (in %) in Panama?
Provide a short and direct response. -0.77. In the year 1970, what is the difference between the Value added (in %) of Dominican Republic and Value added (in %) of Tanzania?
Your answer should be very brief. -4.14. In the year 1970, what is the difference between the Value added (in %) of Dominican Republic and Value added (in %) of Uruguay?
Make the answer very short. -3.66. In the year 1970, what is the difference between the Value added (in %) of Panama and Value added (in %) of Tanzania?
Offer a terse response. -3.37. In the year 1970, what is the difference between the Value added (in %) of Panama and Value added (in %) of Uruguay?
Give a very brief answer. -2.89. In the year 1970, what is the difference between the Value added (in %) of Tanzania and Value added (in %) of Uruguay?
Offer a very short reply. 0.49. In the year 1971, what is the difference between the Value added (in %) of Dominican Republic and Value added (in %) of Panama?
Your answer should be compact. -0.44. In the year 1971, what is the difference between the Value added (in %) of Dominican Republic and Value added (in %) of Tanzania?
Ensure brevity in your answer.  -3.78. In the year 1971, what is the difference between the Value added (in %) in Dominican Republic and Value added (in %) in Uruguay?
Give a very brief answer. -3.84. In the year 1971, what is the difference between the Value added (in %) of Panama and Value added (in %) of Tanzania?
Keep it short and to the point. -3.34. In the year 1971, what is the difference between the Value added (in %) in Panama and Value added (in %) in Uruguay?
Your response must be concise. -3.41. In the year 1971, what is the difference between the Value added (in %) of Tanzania and Value added (in %) of Uruguay?
Keep it short and to the point. -0.07. In the year 1972, what is the difference between the Value added (in %) in Dominican Republic and Value added (in %) in Panama?
Your answer should be compact. -0.67. In the year 1972, what is the difference between the Value added (in %) in Dominican Republic and Value added (in %) in Tanzania?
Provide a succinct answer. -5.04. In the year 1972, what is the difference between the Value added (in %) in Dominican Republic and Value added (in %) in Uruguay?
Your answer should be very brief. -3.66. In the year 1972, what is the difference between the Value added (in %) of Panama and Value added (in %) of Tanzania?
Provide a short and direct response. -4.37. In the year 1972, what is the difference between the Value added (in %) in Panama and Value added (in %) in Uruguay?
Provide a short and direct response. -2.99. In the year 1972, what is the difference between the Value added (in %) in Tanzania and Value added (in %) in Uruguay?
Provide a short and direct response. 1.38. In the year 1973, what is the difference between the Value added (in %) of Dominican Republic and Value added (in %) of Panama?
Offer a very short reply. -0.41. In the year 1973, what is the difference between the Value added (in %) of Dominican Republic and Value added (in %) of Tanzania?
Give a very brief answer. -6.17. In the year 1973, what is the difference between the Value added (in %) in Dominican Republic and Value added (in %) in Uruguay?
Your answer should be compact. -2.61. In the year 1973, what is the difference between the Value added (in %) of Panama and Value added (in %) of Tanzania?
Your answer should be very brief. -5.76. In the year 1973, what is the difference between the Value added (in %) of Panama and Value added (in %) of Uruguay?
Make the answer very short. -2.2. In the year 1973, what is the difference between the Value added (in %) of Tanzania and Value added (in %) of Uruguay?
Offer a terse response. 3.56. In the year 1974, what is the difference between the Value added (in %) of Dominican Republic and Value added (in %) of Panama?
Offer a very short reply. -0.34. In the year 1974, what is the difference between the Value added (in %) in Dominican Republic and Value added (in %) in Tanzania?
Offer a very short reply. -5.37. In the year 1974, what is the difference between the Value added (in %) in Dominican Republic and Value added (in %) in Uruguay?
Offer a very short reply. -2.67. In the year 1974, what is the difference between the Value added (in %) of Panama and Value added (in %) of Tanzania?
Your answer should be compact. -5.03. In the year 1974, what is the difference between the Value added (in %) of Panama and Value added (in %) of Uruguay?
Ensure brevity in your answer.  -2.33. In the year 1974, what is the difference between the Value added (in %) in Tanzania and Value added (in %) in Uruguay?
Your answer should be very brief. 2.7. In the year 1975, what is the difference between the Value added (in %) of Dominican Republic and Value added (in %) of Panama?
Ensure brevity in your answer.  -0.47. In the year 1975, what is the difference between the Value added (in %) of Dominican Republic and Value added (in %) of Tanzania?
Provide a succinct answer. -5.44. In the year 1975, what is the difference between the Value added (in %) in Dominican Republic and Value added (in %) in Uruguay?
Your answer should be compact. -2.14. In the year 1975, what is the difference between the Value added (in %) in Panama and Value added (in %) in Tanzania?
Provide a succinct answer. -4.97. In the year 1975, what is the difference between the Value added (in %) of Panama and Value added (in %) of Uruguay?
Provide a succinct answer. -1.67. In the year 1975, what is the difference between the Value added (in %) of Tanzania and Value added (in %) of Uruguay?
Keep it short and to the point. 3.3. In the year 1978, what is the difference between the Value added (in %) in Dominican Republic and Value added (in %) in Panama?
Offer a terse response. -0.36. In the year 1978, what is the difference between the Value added (in %) of Dominican Republic and Value added (in %) of Tanzania?
Provide a short and direct response. -6.91. In the year 1978, what is the difference between the Value added (in %) of Dominican Republic and Value added (in %) of Uruguay?
Offer a very short reply. -3.82. In the year 1978, what is the difference between the Value added (in %) of Panama and Value added (in %) of Tanzania?
Ensure brevity in your answer.  -6.55. In the year 1978, what is the difference between the Value added (in %) of Panama and Value added (in %) of Uruguay?
Your answer should be compact. -3.46. In the year 1978, what is the difference between the Value added (in %) of Tanzania and Value added (in %) of Uruguay?
Provide a short and direct response. 3.09. In the year 1979, what is the difference between the Value added (in %) in Dominican Republic and Value added (in %) in Panama?
Offer a very short reply. -0.31. In the year 1979, what is the difference between the Value added (in %) of Dominican Republic and Value added (in %) of Tanzania?
Your response must be concise. -5.32. In the year 1979, what is the difference between the Value added (in %) in Dominican Republic and Value added (in %) in Uruguay?
Make the answer very short. -7.51. In the year 1979, what is the difference between the Value added (in %) of Panama and Value added (in %) of Tanzania?
Your answer should be compact. -5. In the year 1979, what is the difference between the Value added (in %) in Panama and Value added (in %) in Uruguay?
Provide a short and direct response. -7.19. In the year 1979, what is the difference between the Value added (in %) of Tanzania and Value added (in %) of Uruguay?
Your answer should be compact. -2.19. What is the ratio of the Value added (in %) of Dominican Republic in 1970 to that in 1971?
Your answer should be compact. 0.7. What is the ratio of the Value added (in %) of Panama in 1970 to that in 1971?
Keep it short and to the point. 1.36. What is the ratio of the Value added (in %) of Tanzania in 1970 to that in 1971?
Keep it short and to the point. 1.07. What is the ratio of the Value added (in %) in Uruguay in 1970 to that in 1971?
Your answer should be compact. 0.93. What is the ratio of the Value added (in %) of Dominican Republic in 1970 to that in 1972?
Your answer should be compact. 0.73. What is the ratio of the Value added (in %) in Panama in 1970 to that in 1972?
Provide a succinct answer. 1.04. What is the ratio of the Value added (in %) of Tanzania in 1970 to that in 1972?
Keep it short and to the point. 0.82. What is the ratio of the Value added (in %) in Uruguay in 1970 to that in 1972?
Offer a terse response. 0.98. What is the ratio of the Value added (in %) in Dominican Republic in 1970 to that in 1973?
Your response must be concise. 0.59. What is the ratio of the Value added (in %) in Panama in 1970 to that in 1973?
Provide a succinct answer. 1.31. What is the ratio of the Value added (in %) of Tanzania in 1970 to that in 1973?
Give a very brief answer. 0.67. What is the ratio of the Value added (in %) of Uruguay in 1970 to that in 1973?
Make the answer very short. 1.31. What is the ratio of the Value added (in %) of Dominican Republic in 1970 to that in 1974?
Offer a terse response. 0.65. What is the ratio of the Value added (in %) in Panama in 1970 to that in 1974?
Make the answer very short. 1.53. What is the ratio of the Value added (in %) in Tanzania in 1970 to that in 1974?
Make the answer very short. 0.77. What is the ratio of the Value added (in %) in Uruguay in 1970 to that in 1974?
Your answer should be very brief. 1.3. What is the ratio of the Value added (in %) of Dominican Republic in 1970 to that in 1975?
Keep it short and to the point. 0.46. What is the ratio of the Value added (in %) of Panama in 1970 to that in 1975?
Provide a short and direct response. 1.1. What is the ratio of the Value added (in %) in Tanzania in 1970 to that in 1975?
Provide a short and direct response. 0.74. What is the ratio of the Value added (in %) in Uruguay in 1970 to that in 1975?
Keep it short and to the point. 1.51. What is the ratio of the Value added (in %) in Dominican Republic in 1970 to that in 1978?
Keep it short and to the point. 0.38. What is the ratio of the Value added (in %) of Panama in 1970 to that in 1978?
Give a very brief answer. 1.12. What is the ratio of the Value added (in %) of Tanzania in 1970 to that in 1978?
Your answer should be compact. 0.58. What is the ratio of the Value added (in %) of Uruguay in 1970 to that in 1978?
Your answer should be compact. 0.89. What is the ratio of the Value added (in %) of Dominican Republic in 1970 to that in 1979?
Give a very brief answer. 0.39. What is the ratio of the Value added (in %) in Panama in 1970 to that in 1979?
Ensure brevity in your answer.  1.22. What is the ratio of the Value added (in %) of Tanzania in 1970 to that in 1979?
Ensure brevity in your answer.  0.75. What is the ratio of the Value added (in %) of Uruguay in 1970 to that in 1979?
Your response must be concise. 0.48. What is the ratio of the Value added (in %) in Dominican Republic in 1971 to that in 1972?
Make the answer very short. 1.06. What is the ratio of the Value added (in %) of Panama in 1971 to that in 1972?
Provide a short and direct response. 0.76. What is the ratio of the Value added (in %) in Tanzania in 1971 to that in 1972?
Keep it short and to the point. 0.76. What is the ratio of the Value added (in %) of Uruguay in 1971 to that in 1972?
Ensure brevity in your answer.  1.05. What is the ratio of the Value added (in %) in Dominican Republic in 1971 to that in 1973?
Your answer should be very brief. 0.84. What is the ratio of the Value added (in %) of Panama in 1971 to that in 1973?
Give a very brief answer. 0.96. What is the ratio of the Value added (in %) in Tanzania in 1971 to that in 1973?
Your answer should be very brief. 0.62. What is the ratio of the Value added (in %) of Uruguay in 1971 to that in 1973?
Your answer should be compact. 1.4. What is the ratio of the Value added (in %) of Dominican Republic in 1971 to that in 1974?
Provide a short and direct response. 0.94. What is the ratio of the Value added (in %) in Panama in 1971 to that in 1974?
Your answer should be very brief. 1.12. What is the ratio of the Value added (in %) of Tanzania in 1971 to that in 1974?
Give a very brief answer. 0.72. What is the ratio of the Value added (in %) in Uruguay in 1971 to that in 1974?
Offer a terse response. 1.39. What is the ratio of the Value added (in %) of Dominican Republic in 1971 to that in 1975?
Ensure brevity in your answer.  0.66. What is the ratio of the Value added (in %) in Panama in 1971 to that in 1975?
Ensure brevity in your answer.  0.81. What is the ratio of the Value added (in %) in Tanzania in 1971 to that in 1975?
Your answer should be compact. 0.69. What is the ratio of the Value added (in %) of Uruguay in 1971 to that in 1975?
Your answer should be compact. 1.62. What is the ratio of the Value added (in %) in Dominican Republic in 1971 to that in 1978?
Offer a terse response. 0.54. What is the ratio of the Value added (in %) in Panama in 1971 to that in 1978?
Offer a terse response. 0.82. What is the ratio of the Value added (in %) in Tanzania in 1971 to that in 1978?
Your answer should be compact. 0.55. What is the ratio of the Value added (in %) in Uruguay in 1971 to that in 1978?
Provide a succinct answer. 0.95. What is the ratio of the Value added (in %) in Dominican Republic in 1971 to that in 1979?
Your answer should be very brief. 0.57. What is the ratio of the Value added (in %) of Panama in 1971 to that in 1979?
Ensure brevity in your answer.  0.9. What is the ratio of the Value added (in %) of Tanzania in 1971 to that in 1979?
Offer a very short reply. 0.7. What is the ratio of the Value added (in %) in Uruguay in 1971 to that in 1979?
Make the answer very short. 0.52. What is the ratio of the Value added (in %) in Dominican Republic in 1972 to that in 1973?
Your answer should be compact. 0.8. What is the ratio of the Value added (in %) of Panama in 1972 to that in 1973?
Give a very brief answer. 1.27. What is the ratio of the Value added (in %) of Tanzania in 1972 to that in 1973?
Make the answer very short. 0.82. What is the ratio of the Value added (in %) in Uruguay in 1972 to that in 1973?
Offer a very short reply. 1.34. What is the ratio of the Value added (in %) of Dominican Republic in 1972 to that in 1974?
Provide a succinct answer. 0.89. What is the ratio of the Value added (in %) in Panama in 1972 to that in 1974?
Offer a very short reply. 1.47. What is the ratio of the Value added (in %) of Tanzania in 1972 to that in 1974?
Your response must be concise. 0.94. What is the ratio of the Value added (in %) in Uruguay in 1972 to that in 1974?
Offer a terse response. 1.32. What is the ratio of the Value added (in %) in Dominican Republic in 1972 to that in 1975?
Give a very brief answer. 0.63. What is the ratio of the Value added (in %) in Panama in 1972 to that in 1975?
Make the answer very short. 1.06. What is the ratio of the Value added (in %) in Tanzania in 1972 to that in 1975?
Your response must be concise. 0.91. What is the ratio of the Value added (in %) in Uruguay in 1972 to that in 1975?
Your response must be concise. 1.54. What is the ratio of the Value added (in %) in Dominican Republic in 1972 to that in 1978?
Keep it short and to the point. 0.51. What is the ratio of the Value added (in %) of Panama in 1972 to that in 1978?
Offer a very short reply. 1.08. What is the ratio of the Value added (in %) in Tanzania in 1972 to that in 1978?
Your answer should be very brief. 0.71. What is the ratio of the Value added (in %) in Uruguay in 1972 to that in 1978?
Your response must be concise. 0.91. What is the ratio of the Value added (in %) of Dominican Republic in 1972 to that in 1979?
Offer a terse response. 0.54. What is the ratio of the Value added (in %) of Panama in 1972 to that in 1979?
Your answer should be compact. 1.18. What is the ratio of the Value added (in %) of Tanzania in 1972 to that in 1979?
Offer a very short reply. 0.91. What is the ratio of the Value added (in %) of Uruguay in 1972 to that in 1979?
Your answer should be very brief. 0.49. What is the ratio of the Value added (in %) of Dominican Republic in 1973 to that in 1974?
Offer a terse response. 1.11. What is the ratio of the Value added (in %) of Panama in 1973 to that in 1974?
Ensure brevity in your answer.  1.17. What is the ratio of the Value added (in %) in Tanzania in 1973 to that in 1974?
Offer a terse response. 1.15. What is the ratio of the Value added (in %) in Dominican Republic in 1973 to that in 1975?
Provide a short and direct response. 0.79. What is the ratio of the Value added (in %) in Panama in 1973 to that in 1975?
Offer a very short reply. 0.84. What is the ratio of the Value added (in %) in Tanzania in 1973 to that in 1975?
Offer a very short reply. 1.11. What is the ratio of the Value added (in %) of Uruguay in 1973 to that in 1975?
Keep it short and to the point. 1.15. What is the ratio of the Value added (in %) of Dominican Republic in 1973 to that in 1978?
Provide a succinct answer. 0.64. What is the ratio of the Value added (in %) of Panama in 1973 to that in 1978?
Ensure brevity in your answer.  0.85. What is the ratio of the Value added (in %) in Tanzania in 1973 to that in 1978?
Your response must be concise. 0.88. What is the ratio of the Value added (in %) in Uruguay in 1973 to that in 1978?
Make the answer very short. 0.68. What is the ratio of the Value added (in %) in Dominican Republic in 1973 to that in 1979?
Offer a terse response. 0.67. What is the ratio of the Value added (in %) of Panama in 1973 to that in 1979?
Offer a very short reply. 0.93. What is the ratio of the Value added (in %) of Tanzania in 1973 to that in 1979?
Your answer should be compact. 1.12. What is the ratio of the Value added (in %) of Uruguay in 1973 to that in 1979?
Provide a short and direct response. 0.37. What is the ratio of the Value added (in %) in Dominican Republic in 1974 to that in 1975?
Your response must be concise. 0.71. What is the ratio of the Value added (in %) of Panama in 1974 to that in 1975?
Make the answer very short. 0.72. What is the ratio of the Value added (in %) of Tanzania in 1974 to that in 1975?
Your answer should be compact. 0.97. What is the ratio of the Value added (in %) in Uruguay in 1974 to that in 1975?
Offer a terse response. 1.16. What is the ratio of the Value added (in %) of Dominican Republic in 1974 to that in 1978?
Provide a short and direct response. 0.58. What is the ratio of the Value added (in %) of Panama in 1974 to that in 1978?
Ensure brevity in your answer.  0.73. What is the ratio of the Value added (in %) of Tanzania in 1974 to that in 1978?
Ensure brevity in your answer.  0.76. What is the ratio of the Value added (in %) in Uruguay in 1974 to that in 1978?
Make the answer very short. 0.68. What is the ratio of the Value added (in %) of Dominican Republic in 1974 to that in 1979?
Offer a terse response. 0.6. What is the ratio of the Value added (in %) in Panama in 1974 to that in 1979?
Give a very brief answer. 0.8. What is the ratio of the Value added (in %) in Tanzania in 1974 to that in 1979?
Your answer should be very brief. 0.98. What is the ratio of the Value added (in %) in Uruguay in 1974 to that in 1979?
Keep it short and to the point. 0.37. What is the ratio of the Value added (in %) in Dominican Republic in 1975 to that in 1978?
Keep it short and to the point. 0.81. What is the ratio of the Value added (in %) in Panama in 1975 to that in 1978?
Give a very brief answer. 1.02. What is the ratio of the Value added (in %) of Tanzania in 1975 to that in 1978?
Make the answer very short. 0.79. What is the ratio of the Value added (in %) of Uruguay in 1975 to that in 1978?
Your answer should be compact. 0.59. What is the ratio of the Value added (in %) of Dominican Republic in 1975 to that in 1979?
Ensure brevity in your answer.  0.85. What is the ratio of the Value added (in %) of Panama in 1975 to that in 1979?
Give a very brief answer. 1.11. What is the ratio of the Value added (in %) of Tanzania in 1975 to that in 1979?
Make the answer very short. 1.01. What is the ratio of the Value added (in %) in Uruguay in 1975 to that in 1979?
Your answer should be very brief. 0.32. What is the ratio of the Value added (in %) of Dominican Republic in 1978 to that in 1979?
Ensure brevity in your answer.  1.05. What is the ratio of the Value added (in %) of Panama in 1978 to that in 1979?
Keep it short and to the point. 1.09. What is the ratio of the Value added (in %) in Tanzania in 1978 to that in 1979?
Give a very brief answer. 1.28. What is the ratio of the Value added (in %) in Uruguay in 1978 to that in 1979?
Offer a very short reply. 0.54. What is the difference between the highest and the second highest Value added (in %) of Dominican Republic?
Your response must be concise. 0.02. What is the difference between the highest and the second highest Value added (in %) of Panama?
Offer a terse response. 0.03. What is the difference between the highest and the second highest Value added (in %) in Tanzania?
Your answer should be very brief. 0.91. What is the difference between the highest and the second highest Value added (in %) in Uruguay?
Your answer should be very brief. 3.66. What is the difference between the highest and the lowest Value added (in %) in Dominican Republic?
Offer a very short reply. 0.31. What is the difference between the highest and the lowest Value added (in %) in Panama?
Keep it short and to the point. 0.33. What is the difference between the highest and the lowest Value added (in %) in Tanzania?
Offer a very short reply. 3.36. What is the difference between the highest and the lowest Value added (in %) in Uruguay?
Make the answer very short. 5.44. 